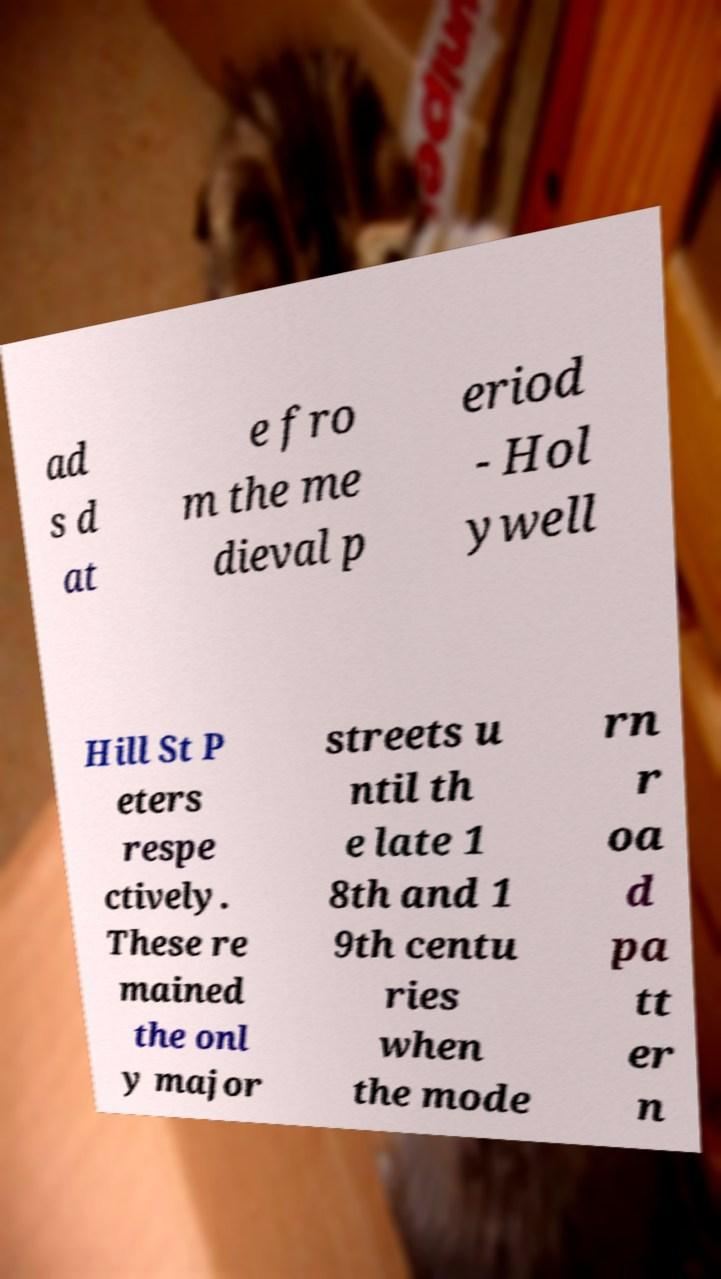For documentation purposes, I need the text within this image transcribed. Could you provide that? ad s d at e fro m the me dieval p eriod - Hol ywell Hill St P eters respe ctively. These re mained the onl y major streets u ntil th e late 1 8th and 1 9th centu ries when the mode rn r oa d pa tt er n 